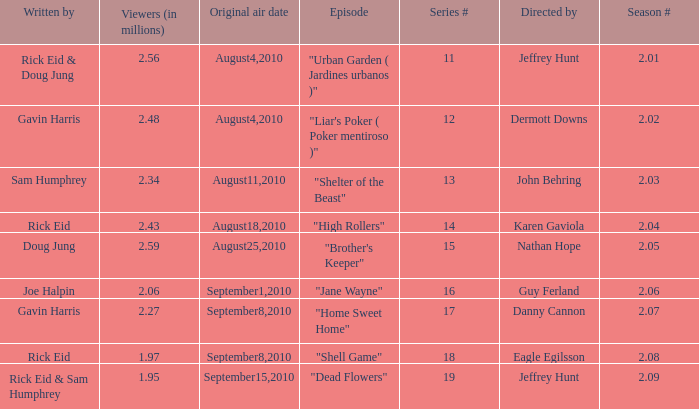What is the series minimum if the season number is 2.08? 18.0. 